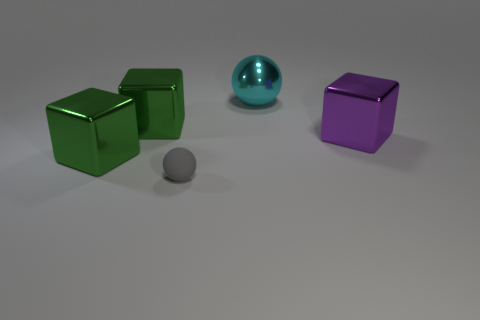Are there fewer large green metallic cubes that are right of the purple shiny cube than small gray objects that are behind the tiny gray object?
Provide a short and direct response. No. The green metal object that is on the right side of the green object in front of the shiny cube right of the rubber object is what shape?
Provide a short and direct response. Cube. There is a cube on the right side of the rubber sphere; does it have the same color as the sphere left of the cyan sphere?
Offer a very short reply. No. What number of metallic things are gray objects or small brown balls?
Ensure brevity in your answer.  0. There is a tiny matte object to the right of the green metal object in front of the large cube that is right of the small gray matte sphere; what color is it?
Provide a short and direct response. Gray. The other object that is the same shape as the cyan shiny object is what color?
Ensure brevity in your answer.  Gray. Is there any other thing of the same color as the rubber object?
Offer a very short reply. No. What number of other things are made of the same material as the tiny gray sphere?
Provide a succinct answer. 0. What size is the cyan sphere?
Provide a short and direct response. Large. Are there any tiny brown matte objects of the same shape as the gray rubber thing?
Provide a short and direct response. No. 